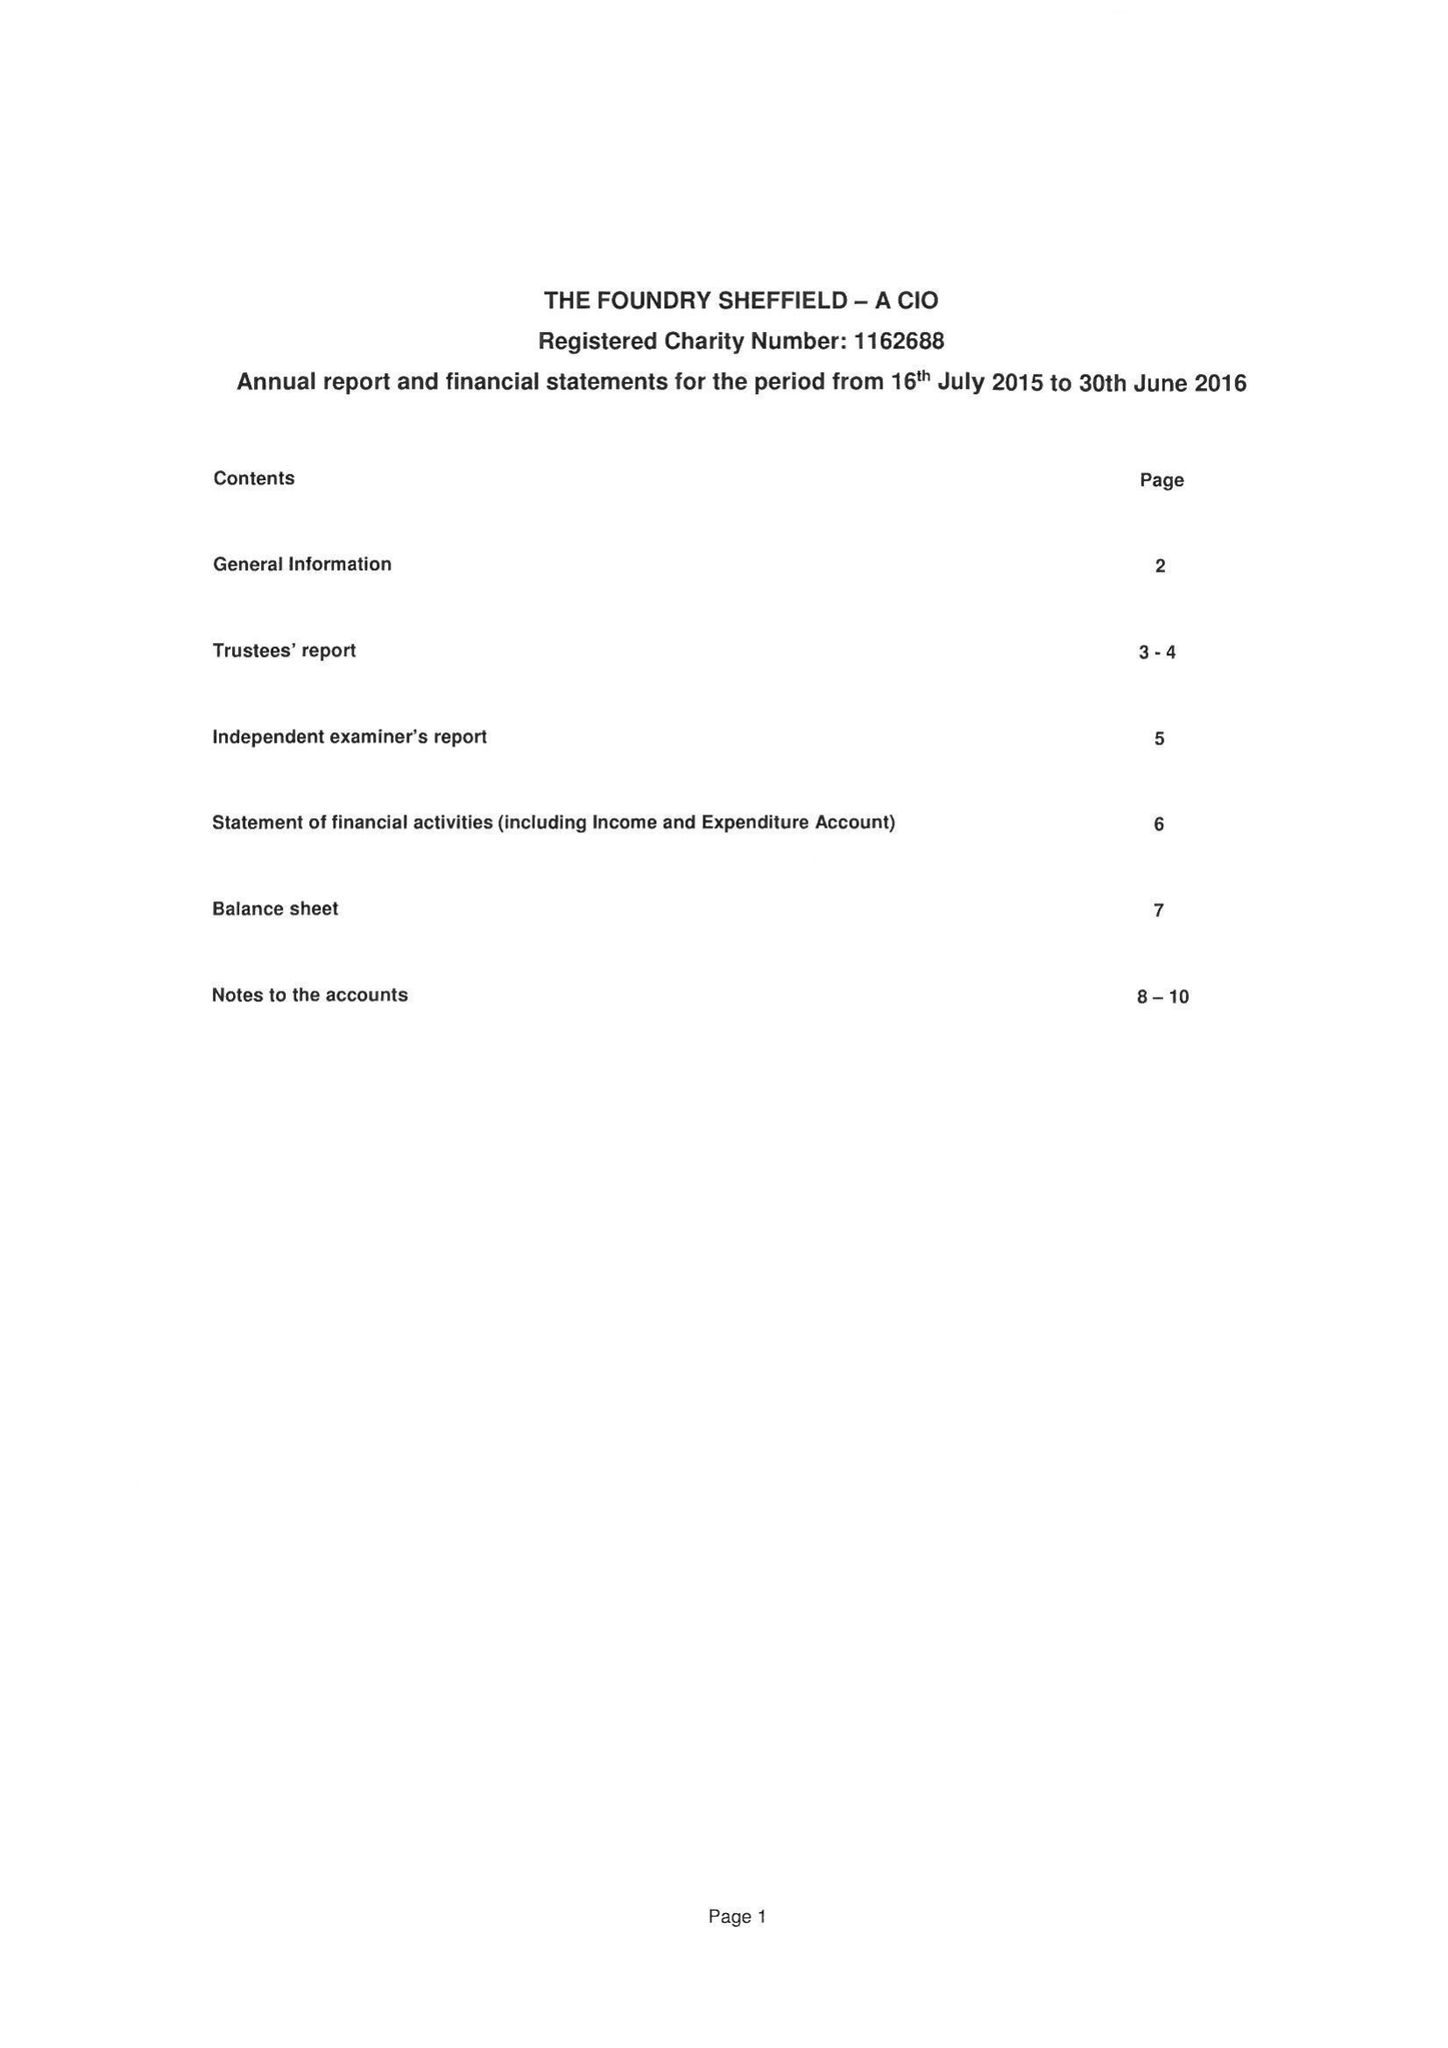What is the value for the report_date?
Answer the question using a single word or phrase. 2016-06-30 